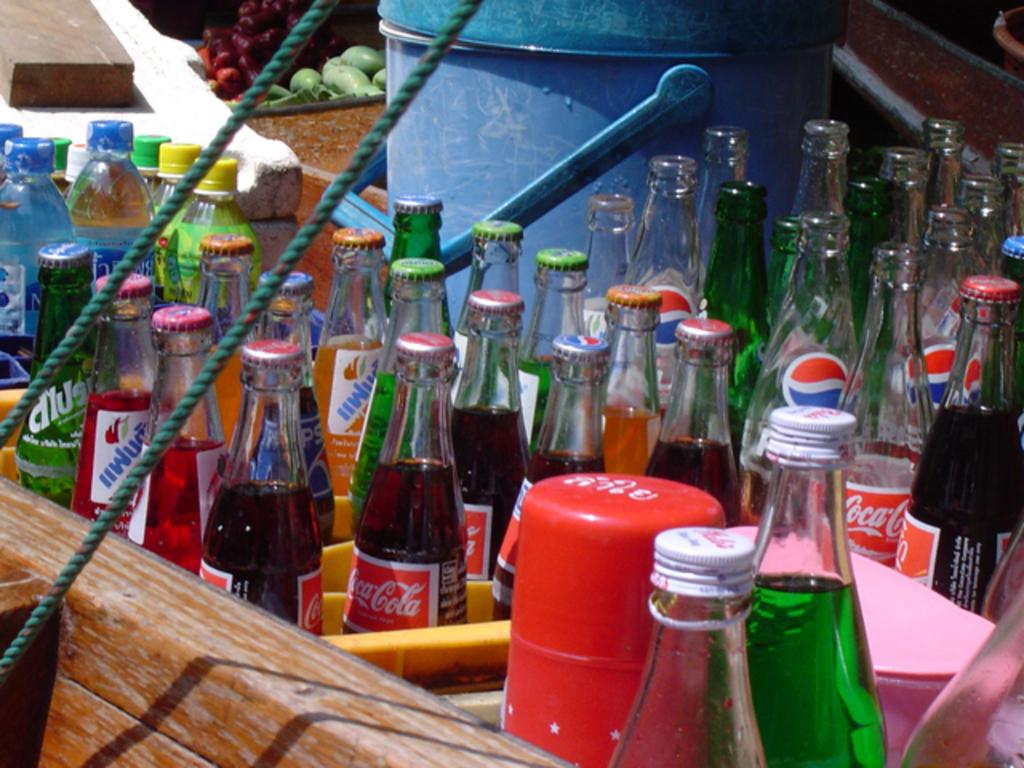<image>
Provide a brief description of the given image. A bunch of glass bottles of coca cola and pepsi vintage. 